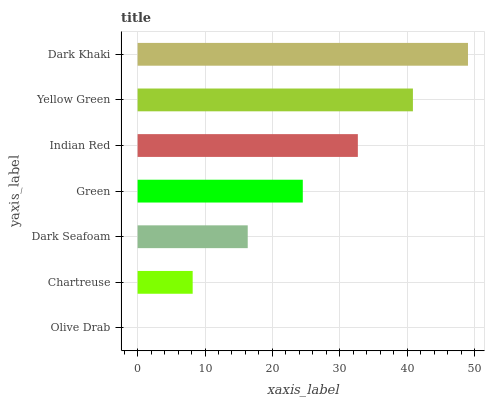Is Olive Drab the minimum?
Answer yes or no. Yes. Is Dark Khaki the maximum?
Answer yes or no. Yes. Is Chartreuse the minimum?
Answer yes or no. No. Is Chartreuse the maximum?
Answer yes or no. No. Is Chartreuse greater than Olive Drab?
Answer yes or no. Yes. Is Olive Drab less than Chartreuse?
Answer yes or no. Yes. Is Olive Drab greater than Chartreuse?
Answer yes or no. No. Is Chartreuse less than Olive Drab?
Answer yes or no. No. Is Green the high median?
Answer yes or no. Yes. Is Green the low median?
Answer yes or no. Yes. Is Olive Drab the high median?
Answer yes or no. No. Is Olive Drab the low median?
Answer yes or no. No. 